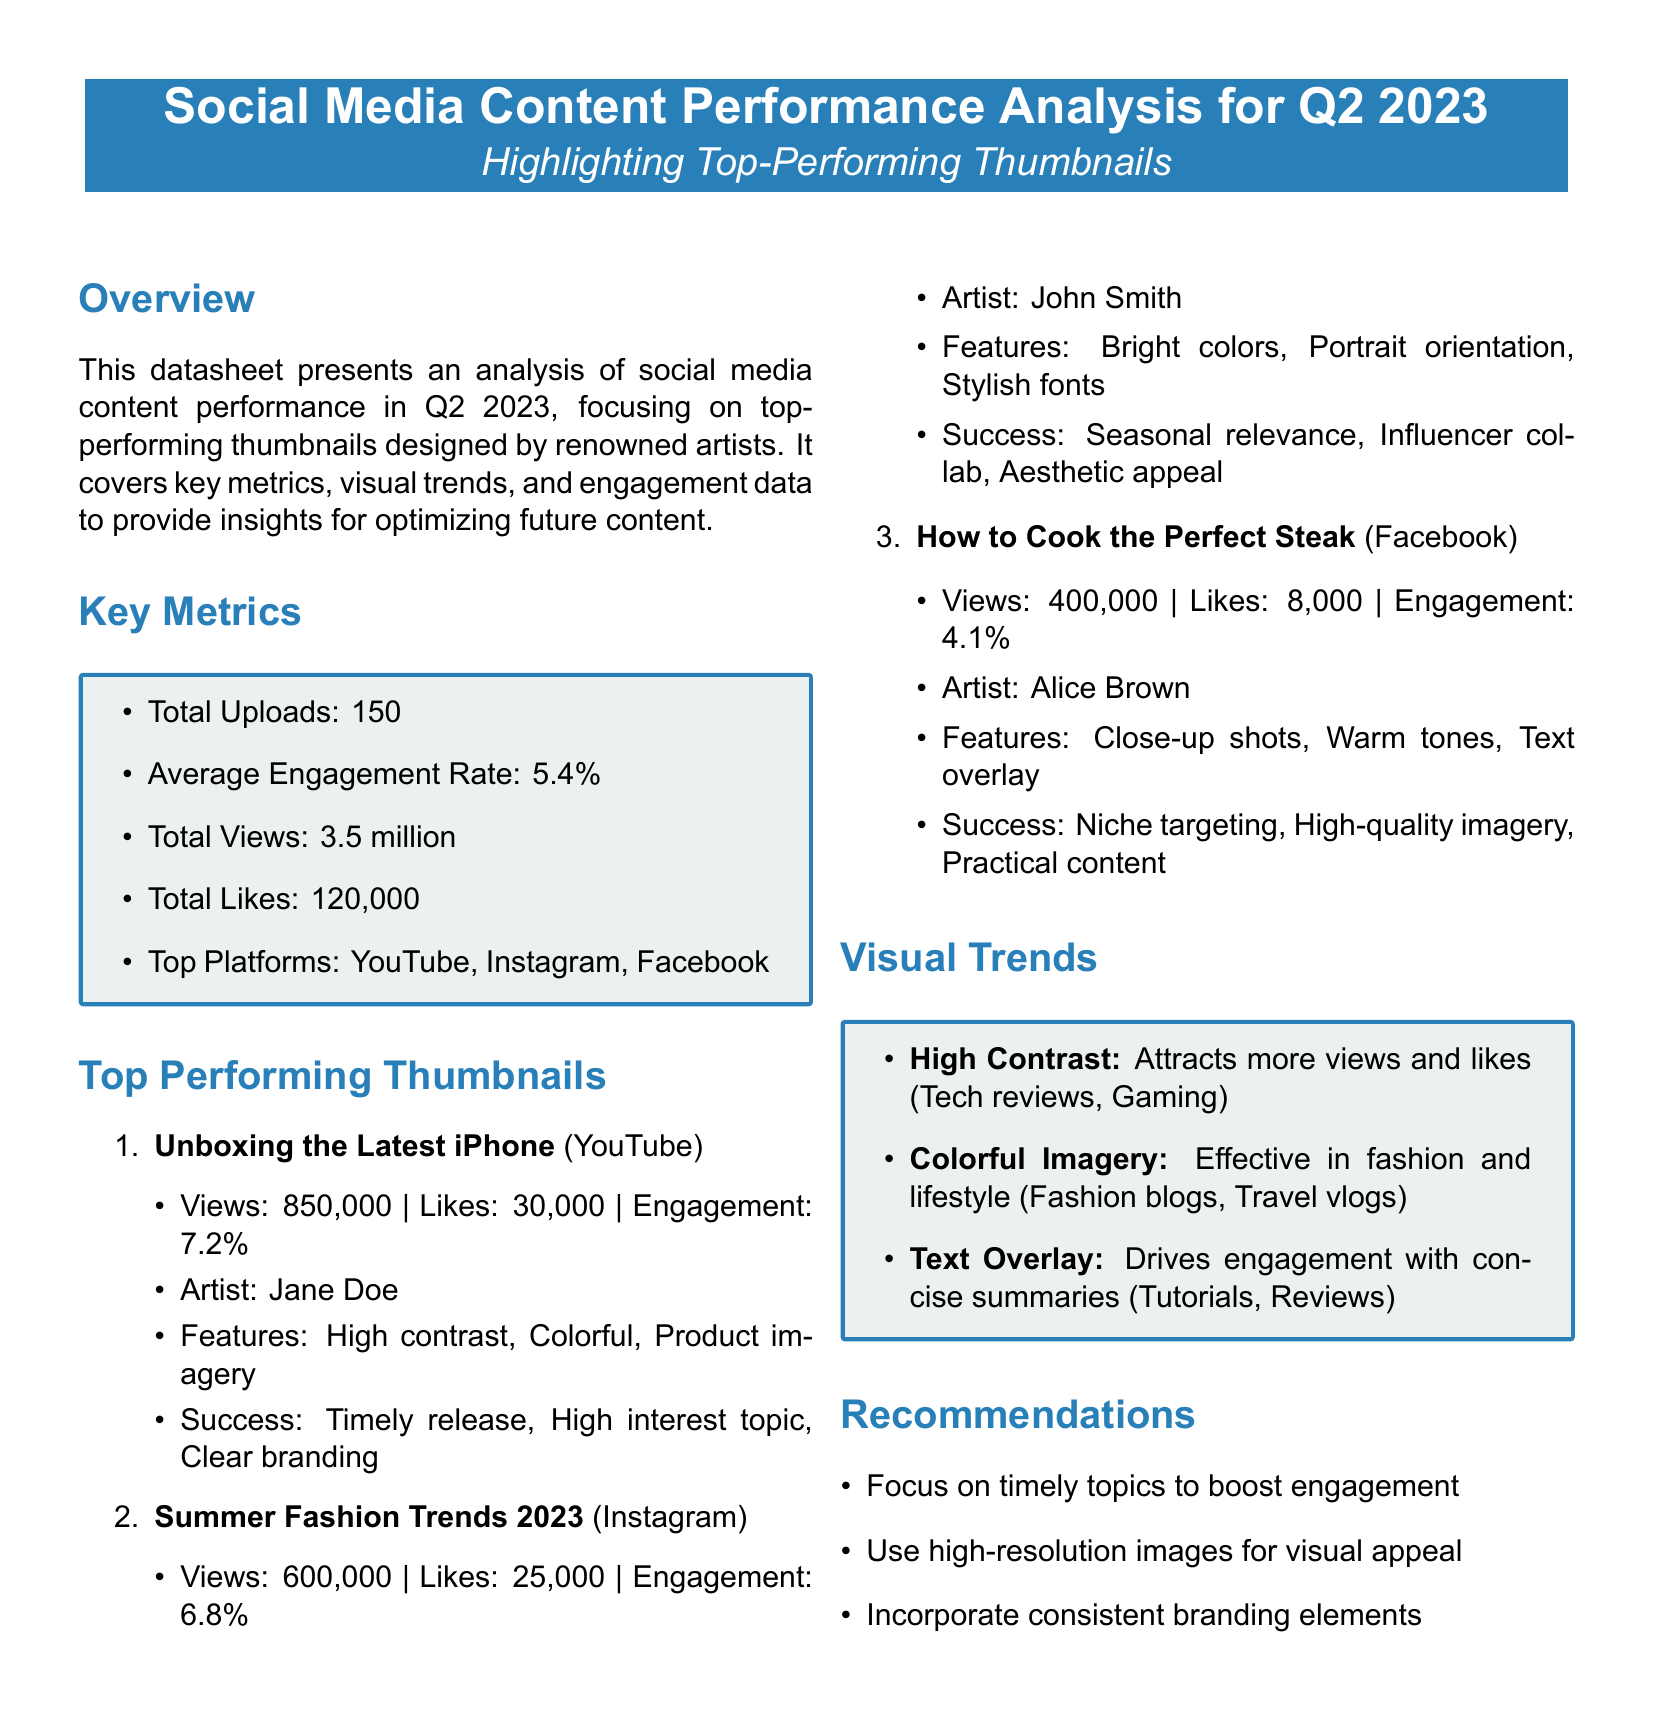what is the total number of uploads? The total number of uploads is listed in the key metrics section of the document.
Answer: 150 who is the artist of the top-performing thumbnail "Unboxing the Latest iPhone"? The artist's name is mentioned in the details of the top-performing thumbnails section.
Answer: Jane Doe what is the engagement rate for "How to Cook the Perfect Steak"? The engagement rate is provided in the details of the thumbnail performance analysis.
Answer: 4.1% which platform has the highest views according to the document? The platform with the highest views is indicated in the data for the top-performing thumbnails.
Answer: YouTube what key visual trend involves using concise summaries? The visual trends section describes a specific trend related to text overlay.
Answer: Text Overlay what is the average engagement rate? The average engagement rate is found in the key metrics section of the document.
Answer: 5.4% which thumbnail was created by John Smith? The artist associated with a specific thumbnail can be found in the top-performing thumbnails section.
Answer: Summer Fashion Trends 2023 what color scheme is noted as effective in fashion content? The visual trends section highlights an effective color scheme specifically for fashion and lifestyle content.
Answer: Colorful Imagery 